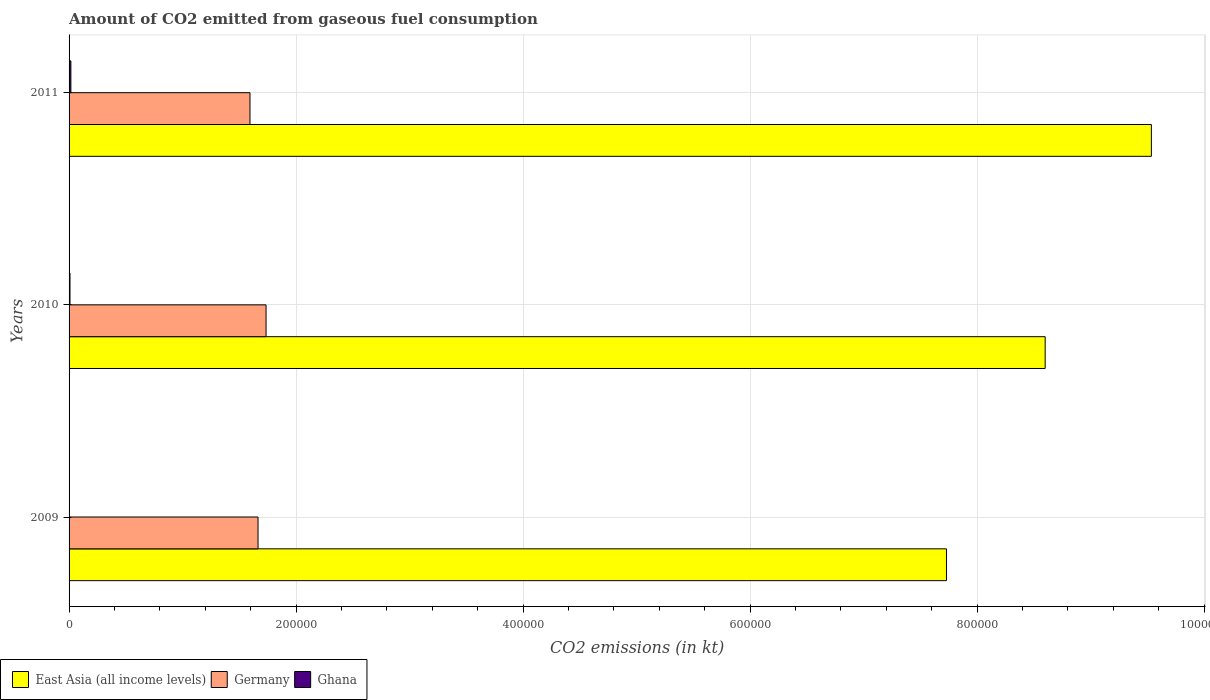Are the number of bars per tick equal to the number of legend labels?
Provide a short and direct response. Yes. What is the amount of CO2 emitted in Ghana in 2011?
Provide a succinct answer. 1584.14. Across all years, what is the maximum amount of CO2 emitted in East Asia (all income levels)?
Keep it short and to the point. 9.54e+05. Across all years, what is the minimum amount of CO2 emitted in Germany?
Provide a succinct answer. 1.59e+05. In which year was the amount of CO2 emitted in Ghana maximum?
Your answer should be very brief. 2011. In which year was the amount of CO2 emitted in Germany minimum?
Your answer should be very brief. 2011. What is the total amount of CO2 emitted in Ghana in the graph?
Keep it short and to the point. 2405.55. What is the difference between the amount of CO2 emitted in Ghana in 2009 and that in 2011?
Give a very brief answer. -1573.14. What is the difference between the amount of CO2 emitted in Ghana in 2010 and the amount of CO2 emitted in Germany in 2011?
Your response must be concise. -1.59e+05. What is the average amount of CO2 emitted in East Asia (all income levels) per year?
Provide a succinct answer. 8.62e+05. In the year 2011, what is the difference between the amount of CO2 emitted in Germany and amount of CO2 emitted in Ghana?
Offer a terse response. 1.58e+05. What is the ratio of the amount of CO2 emitted in East Asia (all income levels) in 2010 to that in 2011?
Ensure brevity in your answer.  0.9. Is the amount of CO2 emitted in Germany in 2009 less than that in 2010?
Keep it short and to the point. Yes. Is the difference between the amount of CO2 emitted in Germany in 2009 and 2011 greater than the difference between the amount of CO2 emitted in Ghana in 2009 and 2011?
Provide a short and direct response. Yes. What is the difference between the highest and the second highest amount of CO2 emitted in Germany?
Provide a succinct answer. 7077.31. What is the difference between the highest and the lowest amount of CO2 emitted in East Asia (all income levels)?
Provide a short and direct response. 1.81e+05. What does the 3rd bar from the top in 2011 represents?
Your answer should be compact. East Asia (all income levels). Is it the case that in every year, the sum of the amount of CO2 emitted in East Asia (all income levels) and amount of CO2 emitted in Ghana is greater than the amount of CO2 emitted in Germany?
Your answer should be very brief. Yes. How many bars are there?
Offer a terse response. 9. What is the difference between two consecutive major ticks on the X-axis?
Keep it short and to the point. 2.00e+05. Are the values on the major ticks of X-axis written in scientific E-notation?
Ensure brevity in your answer.  No. Does the graph contain any zero values?
Make the answer very short. No. How are the legend labels stacked?
Offer a very short reply. Horizontal. What is the title of the graph?
Offer a terse response. Amount of CO2 emitted from gaseous fuel consumption. What is the label or title of the X-axis?
Ensure brevity in your answer.  CO2 emissions (in kt). What is the label or title of the Y-axis?
Give a very brief answer. Years. What is the CO2 emissions (in kt) of East Asia (all income levels) in 2009?
Provide a short and direct response. 7.73e+05. What is the CO2 emissions (in kt) in Germany in 2009?
Offer a terse response. 1.66e+05. What is the CO2 emissions (in kt) in Ghana in 2009?
Provide a succinct answer. 11. What is the CO2 emissions (in kt) of East Asia (all income levels) in 2010?
Offer a very short reply. 8.60e+05. What is the CO2 emissions (in kt) in Germany in 2010?
Ensure brevity in your answer.  1.74e+05. What is the CO2 emissions (in kt) of Ghana in 2010?
Provide a succinct answer. 810.41. What is the CO2 emissions (in kt) in East Asia (all income levels) in 2011?
Offer a terse response. 9.54e+05. What is the CO2 emissions (in kt) in Germany in 2011?
Keep it short and to the point. 1.59e+05. What is the CO2 emissions (in kt) in Ghana in 2011?
Make the answer very short. 1584.14. Across all years, what is the maximum CO2 emissions (in kt) in East Asia (all income levels)?
Ensure brevity in your answer.  9.54e+05. Across all years, what is the maximum CO2 emissions (in kt) of Germany?
Offer a very short reply. 1.74e+05. Across all years, what is the maximum CO2 emissions (in kt) of Ghana?
Your response must be concise. 1584.14. Across all years, what is the minimum CO2 emissions (in kt) in East Asia (all income levels)?
Your answer should be very brief. 7.73e+05. Across all years, what is the minimum CO2 emissions (in kt) in Germany?
Keep it short and to the point. 1.59e+05. Across all years, what is the minimum CO2 emissions (in kt) of Ghana?
Provide a succinct answer. 11. What is the total CO2 emissions (in kt) in East Asia (all income levels) in the graph?
Your answer should be compact. 2.59e+06. What is the total CO2 emissions (in kt) of Germany in the graph?
Provide a short and direct response. 4.99e+05. What is the total CO2 emissions (in kt) in Ghana in the graph?
Provide a succinct answer. 2405.55. What is the difference between the CO2 emissions (in kt) of East Asia (all income levels) in 2009 and that in 2010?
Keep it short and to the point. -8.70e+04. What is the difference between the CO2 emissions (in kt) of Germany in 2009 and that in 2010?
Offer a very short reply. -7077.31. What is the difference between the CO2 emissions (in kt) of Ghana in 2009 and that in 2010?
Provide a short and direct response. -799.41. What is the difference between the CO2 emissions (in kt) of East Asia (all income levels) in 2009 and that in 2011?
Give a very brief answer. -1.81e+05. What is the difference between the CO2 emissions (in kt) of Germany in 2009 and that in 2011?
Provide a succinct answer. 7084.64. What is the difference between the CO2 emissions (in kt) in Ghana in 2009 and that in 2011?
Keep it short and to the point. -1573.14. What is the difference between the CO2 emissions (in kt) in East Asia (all income levels) in 2010 and that in 2011?
Your response must be concise. -9.36e+04. What is the difference between the CO2 emissions (in kt) of Germany in 2010 and that in 2011?
Give a very brief answer. 1.42e+04. What is the difference between the CO2 emissions (in kt) in Ghana in 2010 and that in 2011?
Offer a terse response. -773.74. What is the difference between the CO2 emissions (in kt) of East Asia (all income levels) in 2009 and the CO2 emissions (in kt) of Germany in 2010?
Your answer should be compact. 5.99e+05. What is the difference between the CO2 emissions (in kt) of East Asia (all income levels) in 2009 and the CO2 emissions (in kt) of Ghana in 2010?
Give a very brief answer. 7.72e+05. What is the difference between the CO2 emissions (in kt) of Germany in 2009 and the CO2 emissions (in kt) of Ghana in 2010?
Make the answer very short. 1.66e+05. What is the difference between the CO2 emissions (in kt) of East Asia (all income levels) in 2009 and the CO2 emissions (in kt) of Germany in 2011?
Keep it short and to the point. 6.14e+05. What is the difference between the CO2 emissions (in kt) in East Asia (all income levels) in 2009 and the CO2 emissions (in kt) in Ghana in 2011?
Offer a terse response. 7.71e+05. What is the difference between the CO2 emissions (in kt) in Germany in 2009 and the CO2 emissions (in kt) in Ghana in 2011?
Ensure brevity in your answer.  1.65e+05. What is the difference between the CO2 emissions (in kt) of East Asia (all income levels) in 2010 and the CO2 emissions (in kt) of Germany in 2011?
Offer a very short reply. 7.01e+05. What is the difference between the CO2 emissions (in kt) in East Asia (all income levels) in 2010 and the CO2 emissions (in kt) in Ghana in 2011?
Keep it short and to the point. 8.58e+05. What is the difference between the CO2 emissions (in kt) in Germany in 2010 and the CO2 emissions (in kt) in Ghana in 2011?
Offer a terse response. 1.72e+05. What is the average CO2 emissions (in kt) in East Asia (all income levels) per year?
Ensure brevity in your answer.  8.62e+05. What is the average CO2 emissions (in kt) of Germany per year?
Offer a very short reply. 1.66e+05. What is the average CO2 emissions (in kt) in Ghana per year?
Give a very brief answer. 801.85. In the year 2009, what is the difference between the CO2 emissions (in kt) of East Asia (all income levels) and CO2 emissions (in kt) of Germany?
Your answer should be very brief. 6.07e+05. In the year 2009, what is the difference between the CO2 emissions (in kt) in East Asia (all income levels) and CO2 emissions (in kt) in Ghana?
Your answer should be very brief. 7.73e+05. In the year 2009, what is the difference between the CO2 emissions (in kt) of Germany and CO2 emissions (in kt) of Ghana?
Your answer should be very brief. 1.66e+05. In the year 2010, what is the difference between the CO2 emissions (in kt) of East Asia (all income levels) and CO2 emissions (in kt) of Germany?
Your answer should be very brief. 6.86e+05. In the year 2010, what is the difference between the CO2 emissions (in kt) of East Asia (all income levels) and CO2 emissions (in kt) of Ghana?
Provide a succinct answer. 8.59e+05. In the year 2010, what is the difference between the CO2 emissions (in kt) in Germany and CO2 emissions (in kt) in Ghana?
Offer a terse response. 1.73e+05. In the year 2011, what is the difference between the CO2 emissions (in kt) in East Asia (all income levels) and CO2 emissions (in kt) in Germany?
Offer a very short reply. 7.94e+05. In the year 2011, what is the difference between the CO2 emissions (in kt) in East Asia (all income levels) and CO2 emissions (in kt) in Ghana?
Offer a very short reply. 9.52e+05. In the year 2011, what is the difference between the CO2 emissions (in kt) in Germany and CO2 emissions (in kt) in Ghana?
Give a very brief answer. 1.58e+05. What is the ratio of the CO2 emissions (in kt) in East Asia (all income levels) in 2009 to that in 2010?
Offer a very short reply. 0.9. What is the ratio of the CO2 emissions (in kt) in Germany in 2009 to that in 2010?
Ensure brevity in your answer.  0.96. What is the ratio of the CO2 emissions (in kt) in Ghana in 2009 to that in 2010?
Keep it short and to the point. 0.01. What is the ratio of the CO2 emissions (in kt) of East Asia (all income levels) in 2009 to that in 2011?
Ensure brevity in your answer.  0.81. What is the ratio of the CO2 emissions (in kt) in Germany in 2009 to that in 2011?
Keep it short and to the point. 1.04. What is the ratio of the CO2 emissions (in kt) of Ghana in 2009 to that in 2011?
Give a very brief answer. 0.01. What is the ratio of the CO2 emissions (in kt) of East Asia (all income levels) in 2010 to that in 2011?
Your answer should be very brief. 0.9. What is the ratio of the CO2 emissions (in kt) in Germany in 2010 to that in 2011?
Offer a terse response. 1.09. What is the ratio of the CO2 emissions (in kt) in Ghana in 2010 to that in 2011?
Your answer should be very brief. 0.51. What is the difference between the highest and the second highest CO2 emissions (in kt) of East Asia (all income levels)?
Provide a short and direct response. 9.36e+04. What is the difference between the highest and the second highest CO2 emissions (in kt) in Germany?
Make the answer very short. 7077.31. What is the difference between the highest and the second highest CO2 emissions (in kt) of Ghana?
Offer a very short reply. 773.74. What is the difference between the highest and the lowest CO2 emissions (in kt) in East Asia (all income levels)?
Give a very brief answer. 1.81e+05. What is the difference between the highest and the lowest CO2 emissions (in kt) in Germany?
Provide a succinct answer. 1.42e+04. What is the difference between the highest and the lowest CO2 emissions (in kt) in Ghana?
Give a very brief answer. 1573.14. 